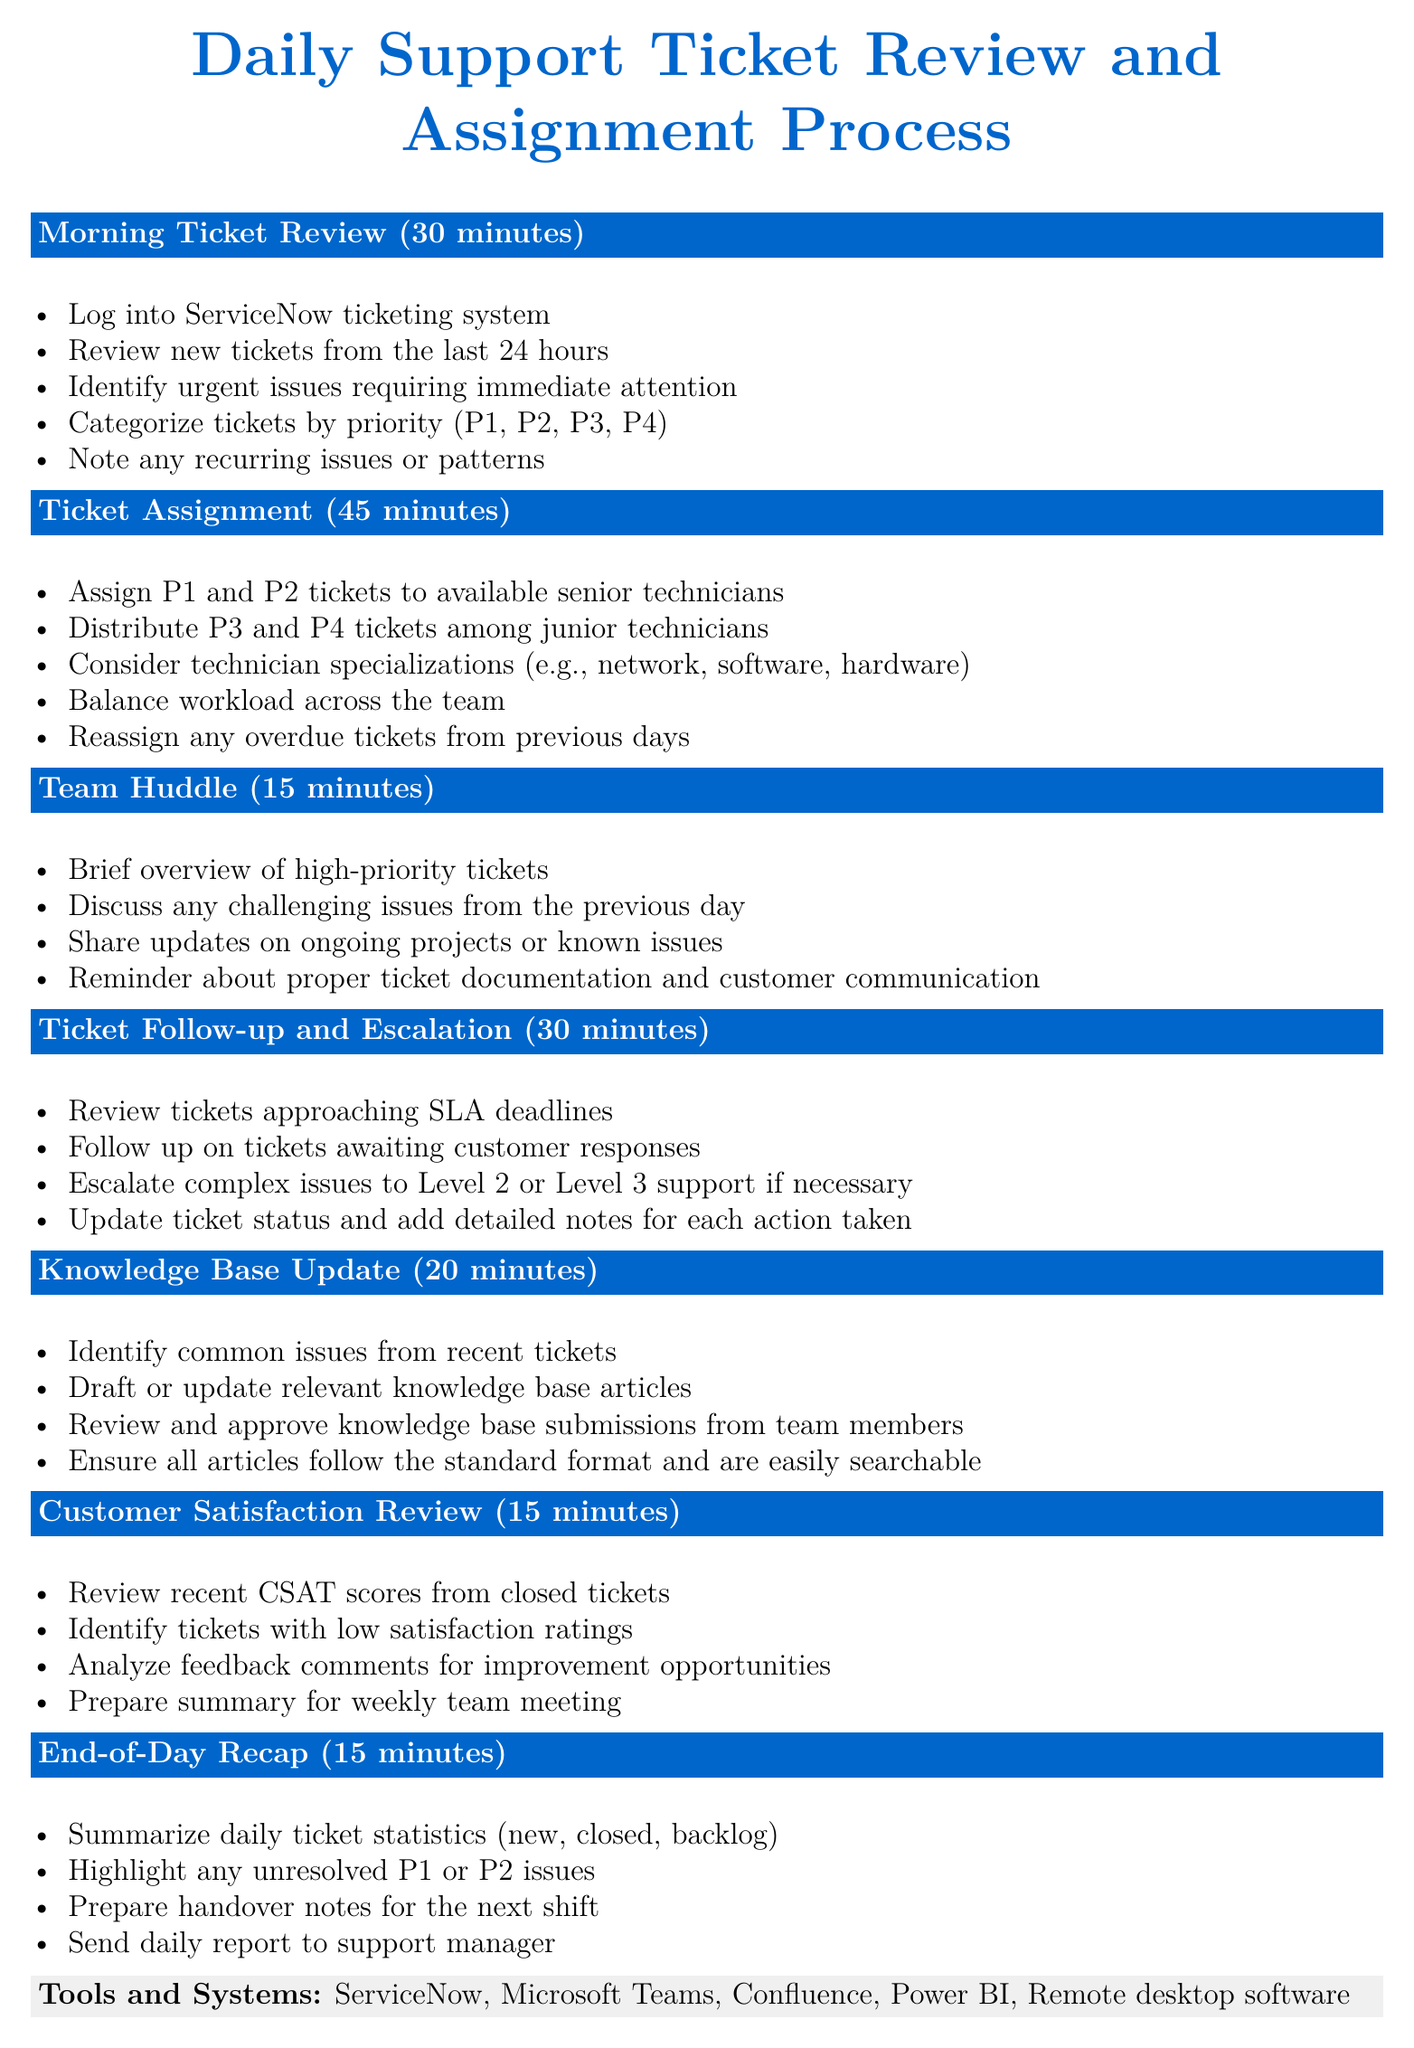What is the duration of the Morning Ticket Review? The document states that the Morning Ticket Review lasts for 30 minutes.
Answer: 30 minutes How many minutes are allocated for Ticket Assignment? The agenda specifies that Ticket Assignment takes 45 minutes.
Answer: 45 minutes What is one of the key reminders regarding customer communication? One of the reminders is to use clear, jargon-free language when communicating with customers.
Answer: Clear, jargon-free language Which system is used for ticket management? The document lists ServiceNow as the tool for ticket management.
Answer: ServiceNow What are the two types of tickets assigned to senior technicians? The agenda states that P1 and P2 tickets are assigned to available senior technicians.
Answer: P1 and P2 How long is the Customer Satisfaction Review segment? According to the agenda, the Customer Satisfaction Review lasts for 15 minutes.
Answer: 15 minutes What should be done during the Team Huddle? The Team Huddle includes a brief overview of high-priority tickets.
Answer: Brief overview of high-priority tickets What action is taken during the Ticket Follow-up and Escalation segment? Tickets approaching SLA deadlines are reviewed during this segment.
Answer: Review tickets approaching SLA deadlines What is required for knowledge base articles? The document states that all articles must follow the standard format and be easily searchable.
Answer: Standard format and easily searchable 